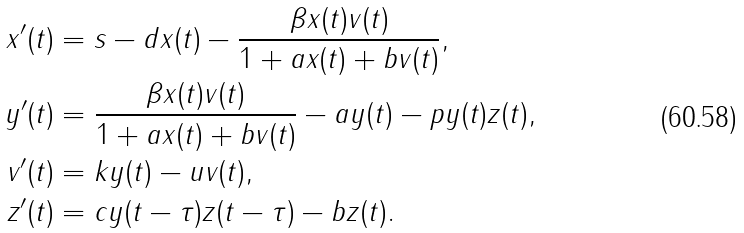<formula> <loc_0><loc_0><loc_500><loc_500>x ^ { \prime } ( t ) & = s - d x ( t ) - \frac { \beta x ( t ) v ( t ) } { 1 + a x ( t ) + b v ( t ) } , \\ y ^ { \prime } ( t ) & = \frac { \beta x ( t ) v ( t ) } { 1 + a x ( t ) + b v ( t ) } - a y ( t ) - p y ( t ) z ( t ) , \\ v ^ { \prime } ( t ) & = k y ( t ) - u v ( t ) , \\ z ^ { \prime } ( t ) & = c y ( t - \tau ) z ( t - \tau ) - b z ( t ) .</formula> 